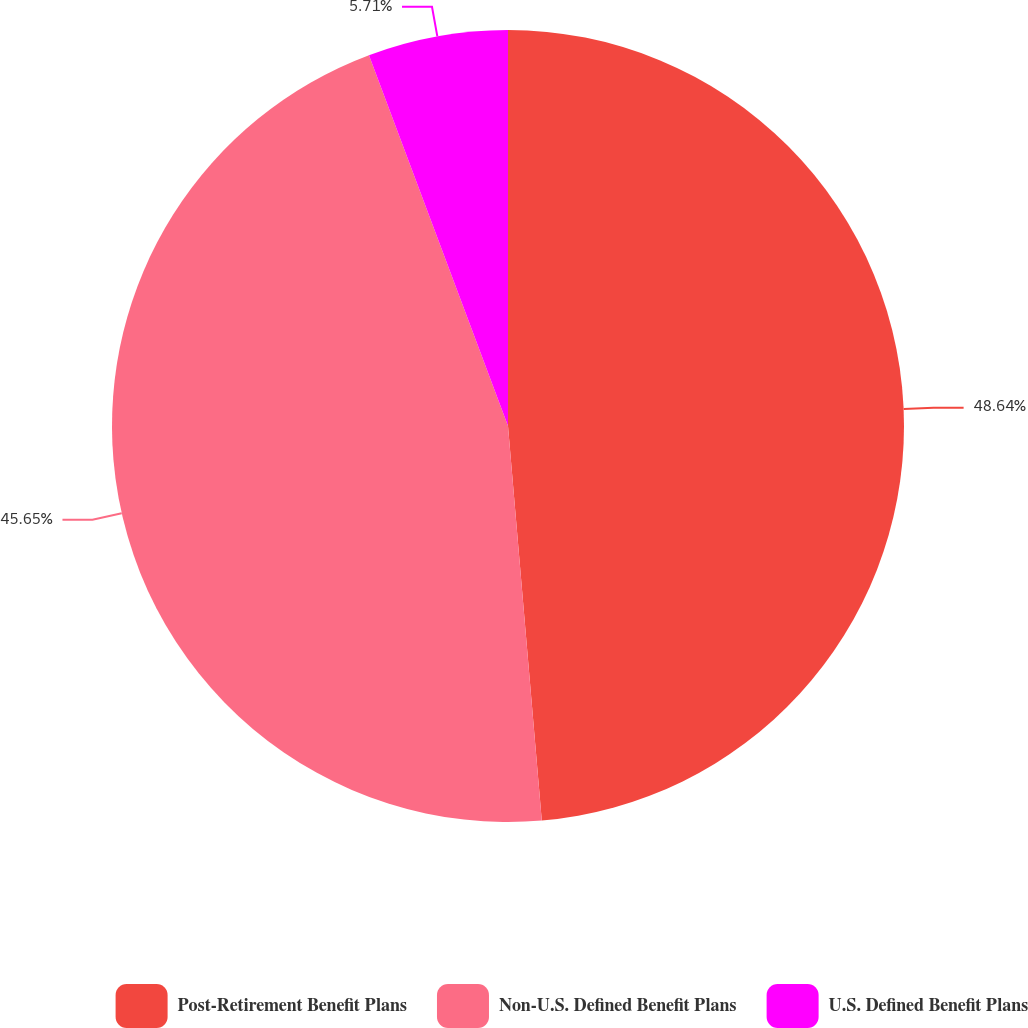<chart> <loc_0><loc_0><loc_500><loc_500><pie_chart><fcel>Post-Retirement Benefit Plans<fcel>Non-U.S. Defined Benefit Plans<fcel>U.S. Defined Benefit Plans<nl><fcel>48.64%<fcel>45.65%<fcel>5.71%<nl></chart> 